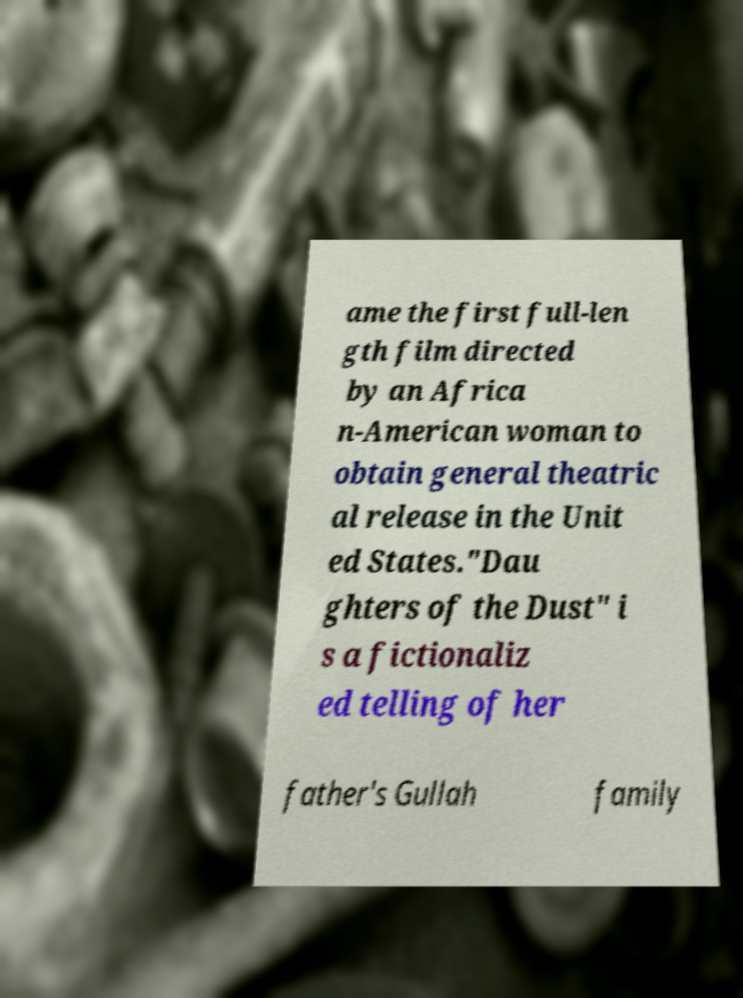What messages or text are displayed in this image? I need them in a readable, typed format. ame the first full-len gth film directed by an Africa n-American woman to obtain general theatric al release in the Unit ed States."Dau ghters of the Dust" i s a fictionaliz ed telling of her father's Gullah family 